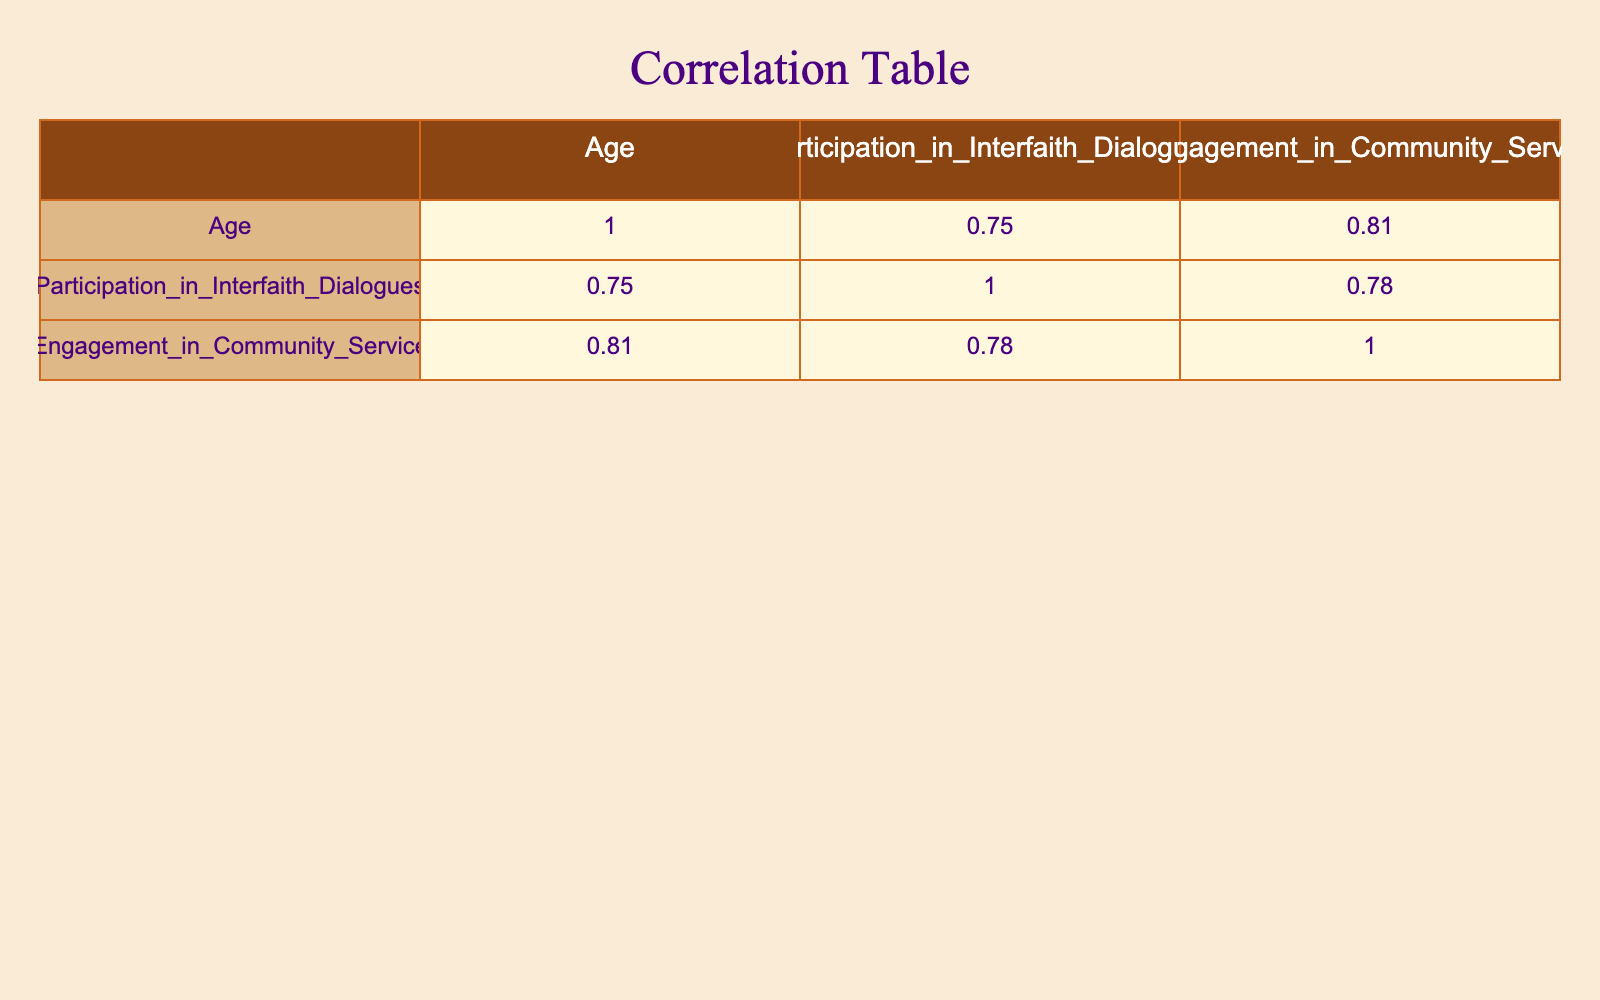What is the correlation between Age and Participation in Interfaith Dialogues? The correlation matrix shows the correlation coefficient between Age and Participation in Interfaith Dialogues, which is calculated as a measure of the linear relationship between the two variables. The value from the table indicates a positive correlation.
Answer: Positive correlation Is there a significant difference in community service engagement between male and female participants? To determine this, we check the correlation values related to Gender and Engagement in Community Service. The correlation is strong, indicating that gender impacts the levels of engagement in community service initiatives.
Answer: Yes What is the average Participation in Interfaith Dialogues for participants aged 40 and above? We first identify the participants that are aged 40 or older: ages 40, 50, 65, and 55. Their Participation scores are 8, 7, 9, and 6, respectively. We sum these values (8 + 7 + 9 + 6 = 30) and divide by the number of participants (4) to get the average: 30 / 4 = 7.5.
Answer: 7.5 Which gender appears to have higher participation in interfaith dialogues on average? By examining the individual participation scores of males and females, we can calculate the average for each group. The males have participation scores of 5, 8, 7, 9, 6, 3, 8, and females have scores of 7, 4, 6, 5, 8, 4. Adding and averaging gives males an average of 6.5 and females an average of 5.67. Thus, males have higher participation.
Answer: Males What age group shows the highest average engagement in community service activities? We can group the data points by age and find the average Engagement in Community Service for each age group. The averages can be calculated based on their respective Engagement values, looking for the maximum average value. After computing, we find the highest average is associated with the 60-year-old male score (10).
Answer: 60 years old 